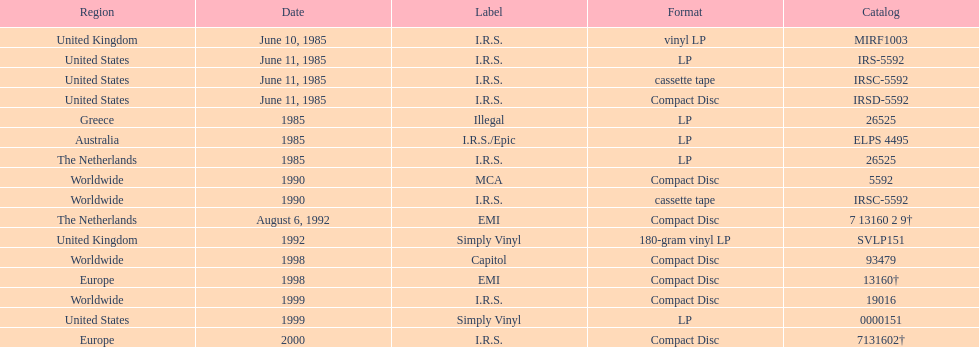On which date was the premiere vinyl lp unveiled? June 10, 1985. 